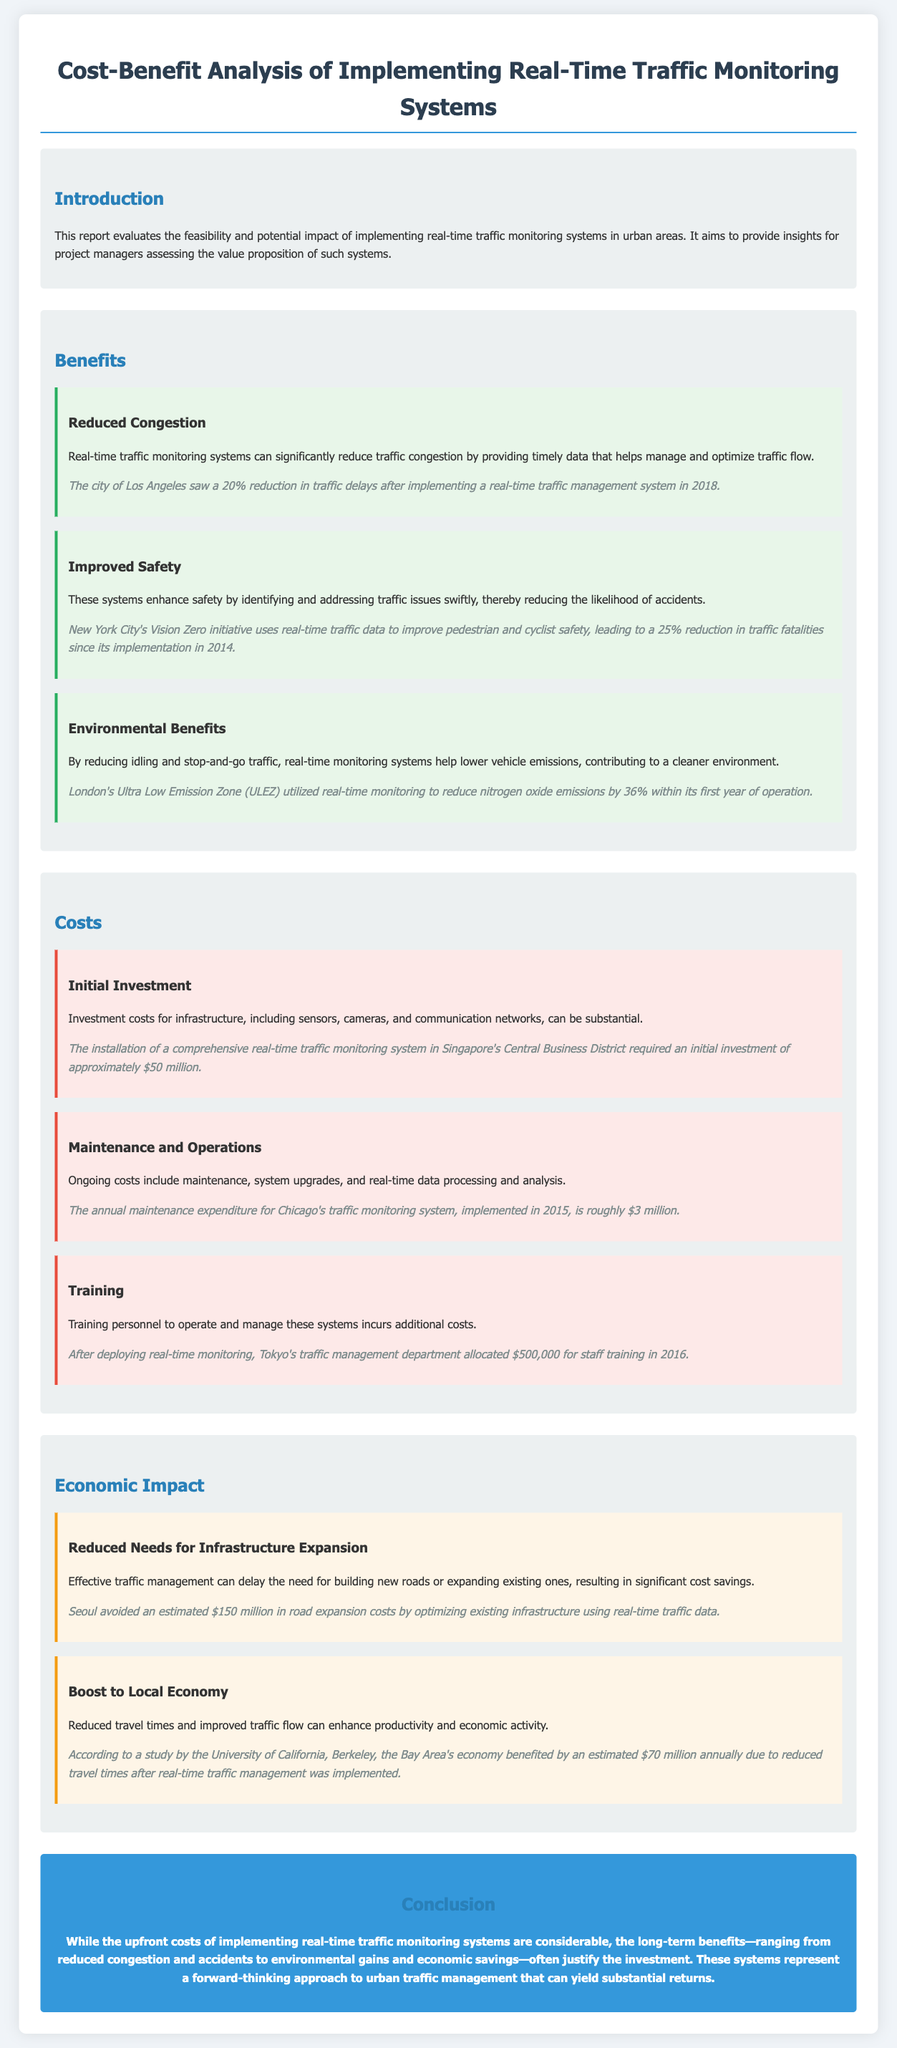What is the main purpose of the report? The report evaluates the feasibility and potential impact of implementing real-time traffic monitoring systems in urban areas.
Answer: Evaluates feasibility and impact How much did Singapore invest for traffic monitoring? The installation of a comprehensive real-time traffic monitoring system in Singapore's Central Business District required an initial investment of approximately $50 million.
Answer: $50 million What reduction in traffic fatalities was achieved by NYC's Vision Zero initiative? New York City's Vision Zero initiative has led to a 25% reduction in traffic fatalities since its implementation in 2014.
Answer: 25% What economic benefit was reported for the Bay Area? According to a study by the University of California, Berkeley, the Bay Area's economy benefited by an estimated $70 million annually due to reduced travel times after real-time traffic management was implemented.
Answer: $70 million What is one ongoing cost mentioned in the report? Ongoing costs include maintenance, system upgrades, and real-time data processing and analysis.
Answer: Maintenance How much did Tokyo allocate for staff training in 2016? After deploying real-time monitoring, Tokyo's traffic management department allocated $500,000 for staff training in 2016.
Answer: $500,000 What is a key environmental benefit of real-time traffic monitoring? By reducing idling and stop-and-go traffic, real-time monitoring systems help lower vehicle emissions, contributing to a cleaner environment.
Answer: Lower vehicle emissions What impact can effective traffic management have on infrastructure needs? Effective traffic management can delay the need for building new roads or expanding existing ones, resulting in significant cost savings.
Answer: Delay infrastructure expansion 